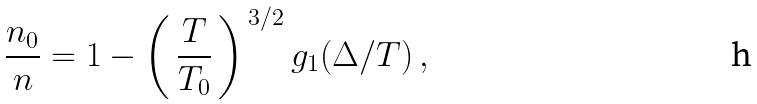Convert formula to latex. <formula><loc_0><loc_0><loc_500><loc_500>\frac { n _ { 0 } } { n } = 1 - \left ( \, \frac { T } { T _ { 0 } } \, \right ) ^ { \, 3 / 2 } g _ { 1 } ( { \Delta } / { T } ) \, ,</formula> 